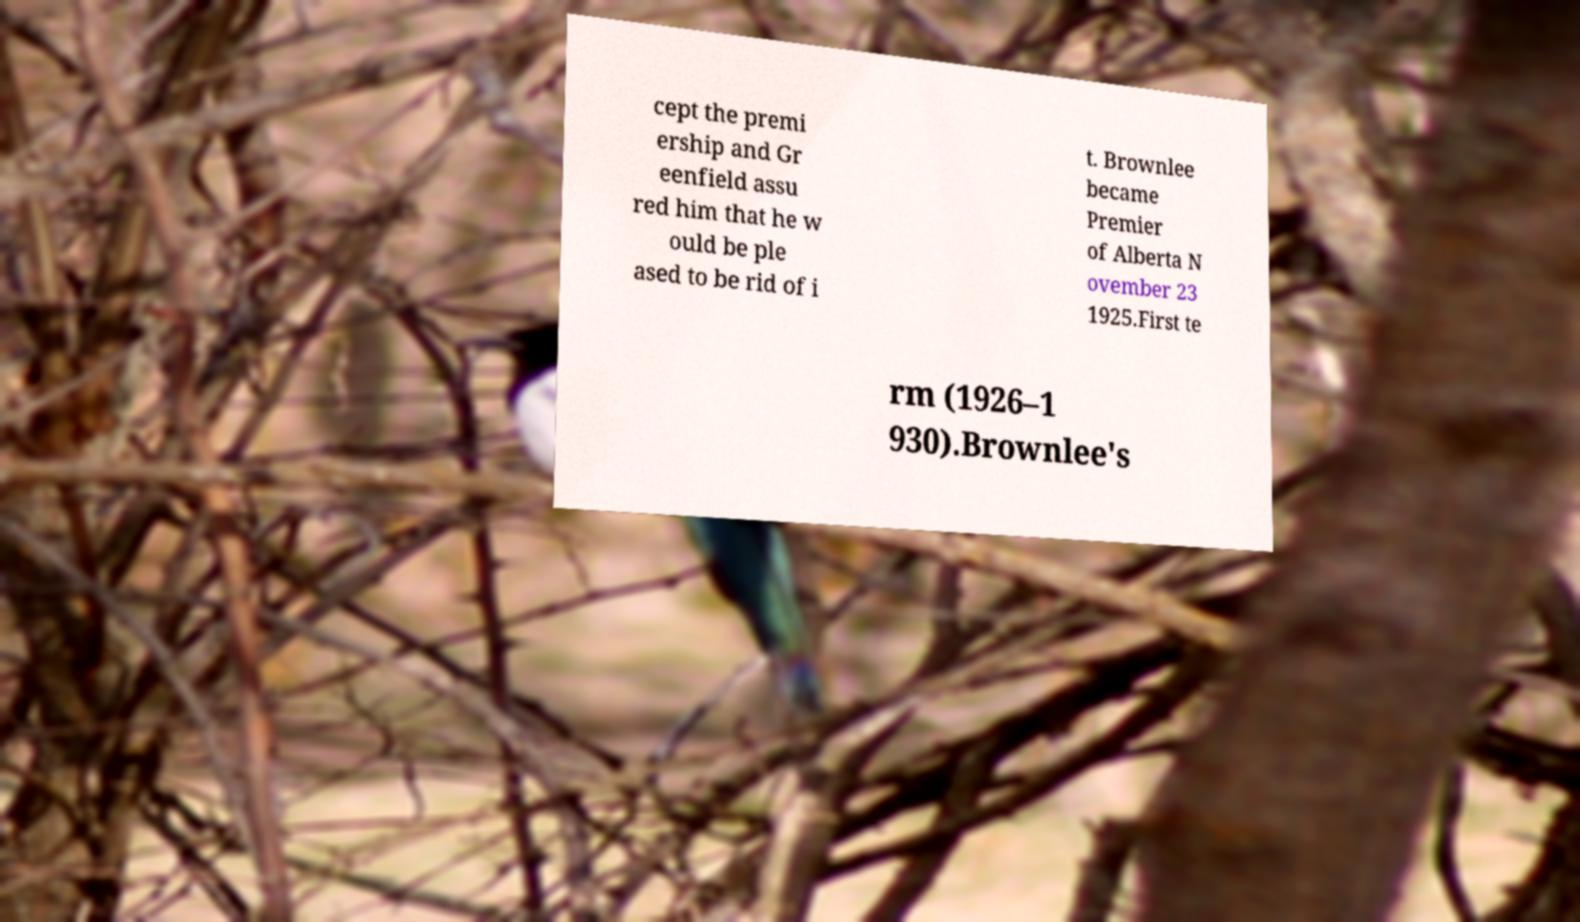There's text embedded in this image that I need extracted. Can you transcribe it verbatim? cept the premi ership and Gr eenfield assu red him that he w ould be ple ased to be rid of i t. Brownlee became Premier of Alberta N ovember 23 1925.First te rm (1926–1 930).Brownlee's 